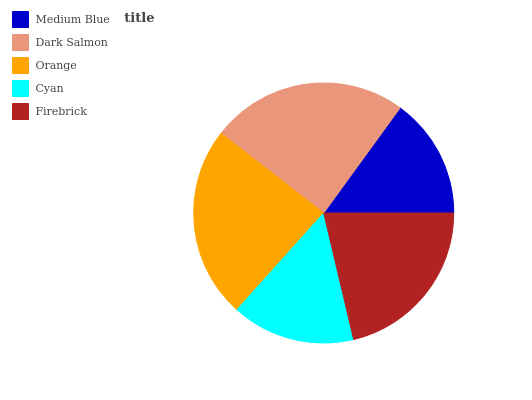Is Medium Blue the minimum?
Answer yes or no. Yes. Is Dark Salmon the maximum?
Answer yes or no. Yes. Is Orange the minimum?
Answer yes or no. No. Is Orange the maximum?
Answer yes or no. No. Is Dark Salmon greater than Orange?
Answer yes or no. Yes. Is Orange less than Dark Salmon?
Answer yes or no. Yes. Is Orange greater than Dark Salmon?
Answer yes or no. No. Is Dark Salmon less than Orange?
Answer yes or no. No. Is Firebrick the high median?
Answer yes or no. Yes. Is Firebrick the low median?
Answer yes or no. Yes. Is Orange the high median?
Answer yes or no. No. Is Medium Blue the low median?
Answer yes or no. No. 